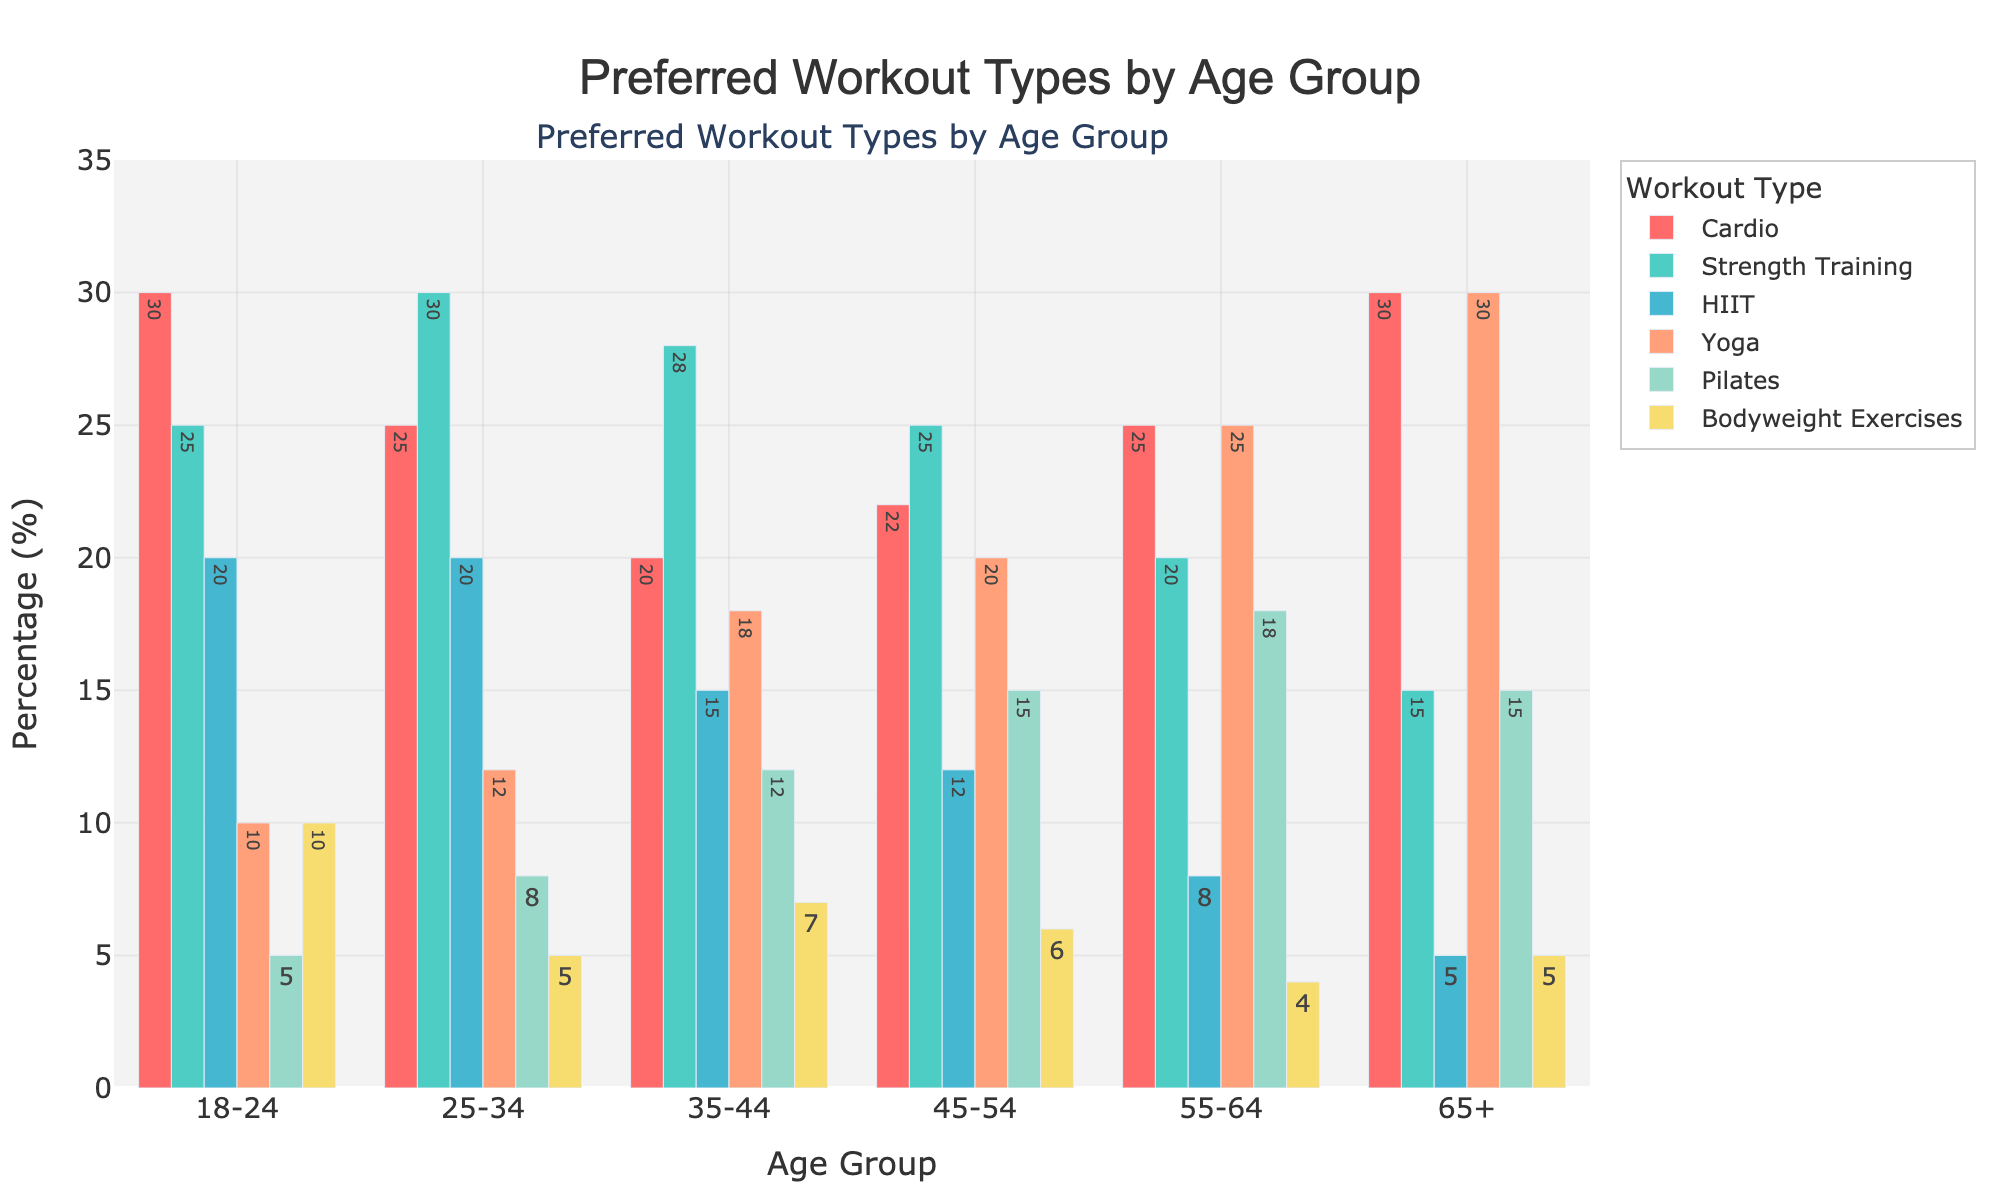Which workout type is most preferred by the 18-24 age group? To determine the most preferred workout type for the 18-24 age group, we look at the values for each type and find the highest one. Cardio has the highest value at 30.
Answer: Cardio What is the least preferred workout type for the 45-54 age group? We need to identify the smallest value among all workout types for the 45-54 age group. Bodyweight Exercises have the smallest value, which is 6.
Answer: Bodyweight Exercises Which age group has the highest overall preference for Yoga? By comparing the values for Yoga across all age groups, the 65+ group has the highest value at 30.
Answer: 65+ How many more people in the 25-34 age group prefer Strength Training over Pilates? To find the difference, subtract the number preferring Pilates (8) from those preferring Strength Training (30): 30 - 8 = 22.
Answer: 22 Compare the preferences for HIIT between the 35-44 and 55-64 age groups. Which group prefers it more? Looking at the values for HIIT, the 35-44 age group has a preference of 15, whereas the 55-64 group has a preference of 8. The 35-44 age group prefers it more.
Answer: 35-44 What is the sum of the preferences for Bodyweight Exercises across all age groups? Add the numbers for Bodyweight Exercises from all age groups: 10 + 5 + 7 + 6 + 4 + 5 = 37.
Answer: 37 Which age group shows the smallest preference for Strength Training? By comparing the Strength Training values, the 65+ age group has the smallest preference at 15.
Answer: 65+ On average, how many people prefer Cardio in the age groups 18-24 and 65+? Calculate the average by adding the values for these age groups and dividing by 2: (30 + 30) / 2 = 30.
Answer: 30 What is the difference in preference for Yoga between the 45-54 and 55-64 age groups? Subtract the value for the 45-54 group (20) from the value for the 55-64 group (25): 25 - 20 = 5.
Answer: 5 Which workout type has the most uniform preference across all age groups? For each workout type, we will observe the spread of their values across all age groups. Cardio and Strength Training show relatively stable values, but Cardio is the most consistent, with preference values between 20 and 30 in all age groups.
Answer: Cardio 